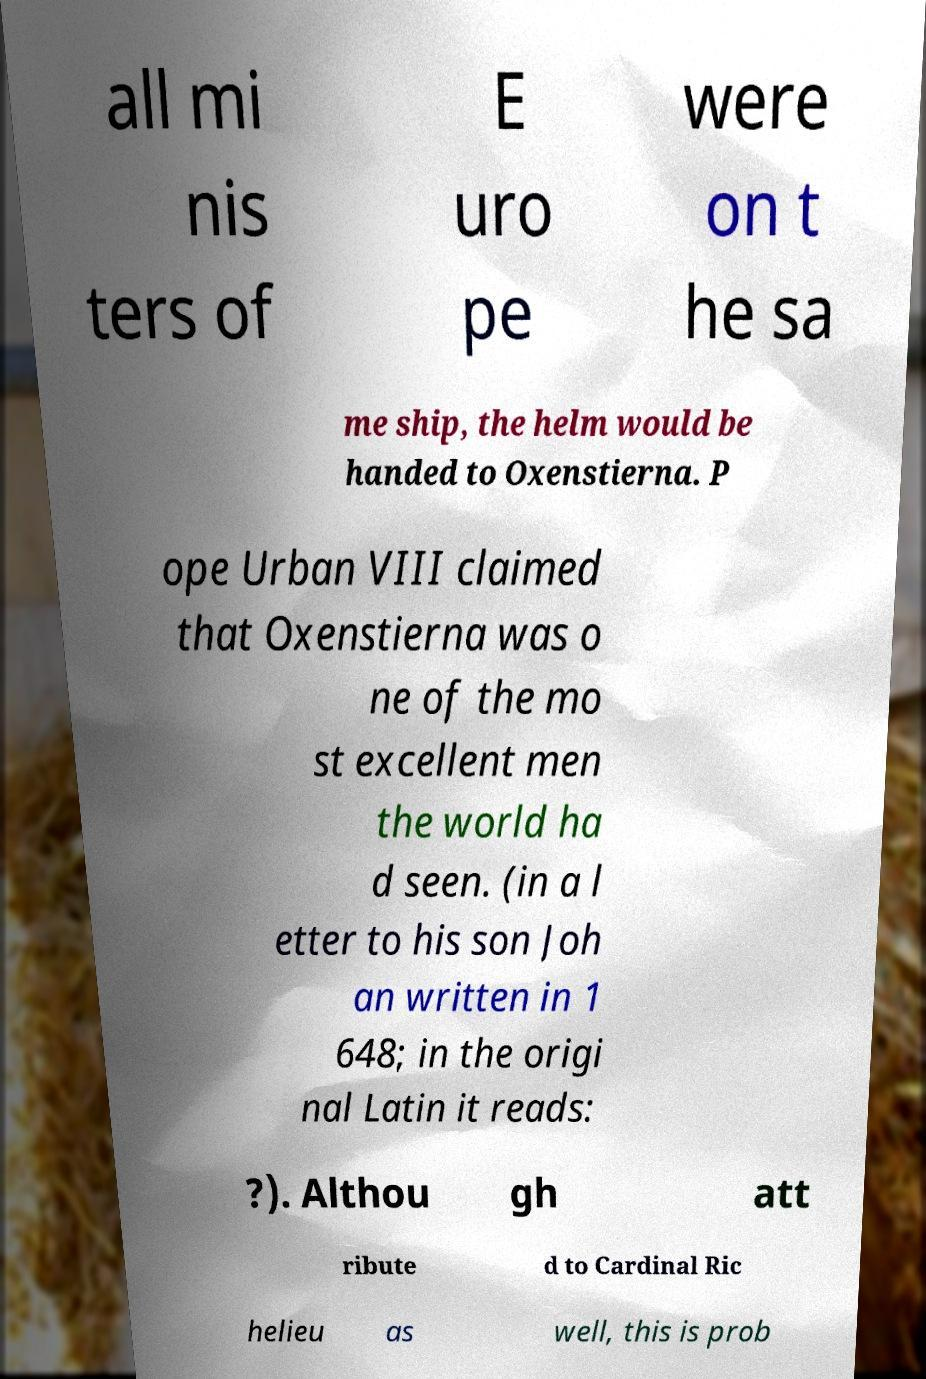Please identify and transcribe the text found in this image. all mi nis ters of E uro pe were on t he sa me ship, the helm would be handed to Oxenstierna. P ope Urban VIII claimed that Oxenstierna was o ne of the mo st excellent men the world ha d seen. (in a l etter to his son Joh an written in 1 648; in the origi nal Latin it reads: ?). Althou gh att ribute d to Cardinal Ric helieu as well, this is prob 